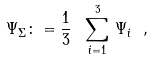<formula> <loc_0><loc_0><loc_500><loc_500>\Psi _ { \Sigma } \colon = \frac { 1 } { 3 } \ \sum _ { i = 1 } ^ { 3 } \, \Psi _ { i } \ ,</formula> 